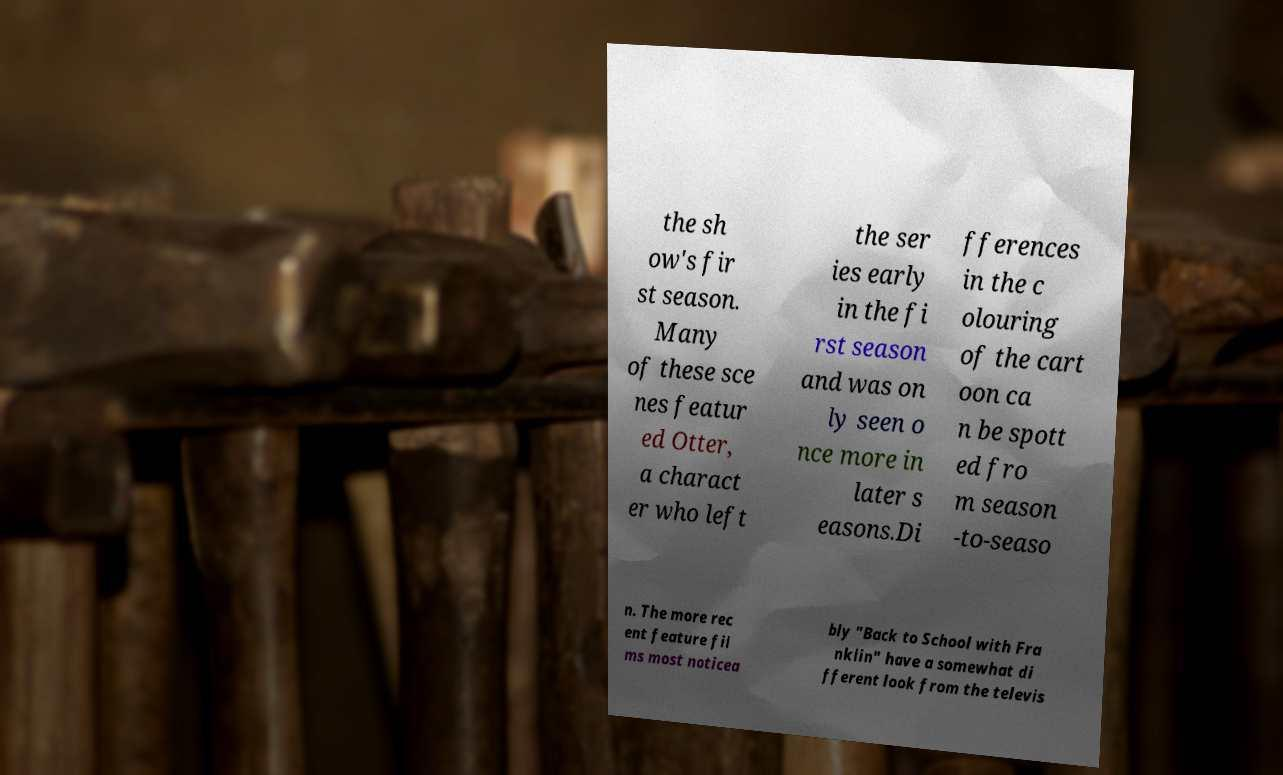I need the written content from this picture converted into text. Can you do that? the sh ow's fir st season. Many of these sce nes featur ed Otter, a charact er who left the ser ies early in the fi rst season and was on ly seen o nce more in later s easons.Di fferences in the c olouring of the cart oon ca n be spott ed fro m season -to-seaso n. The more rec ent feature fil ms most noticea bly "Back to School with Fra nklin" have a somewhat di fferent look from the televis 